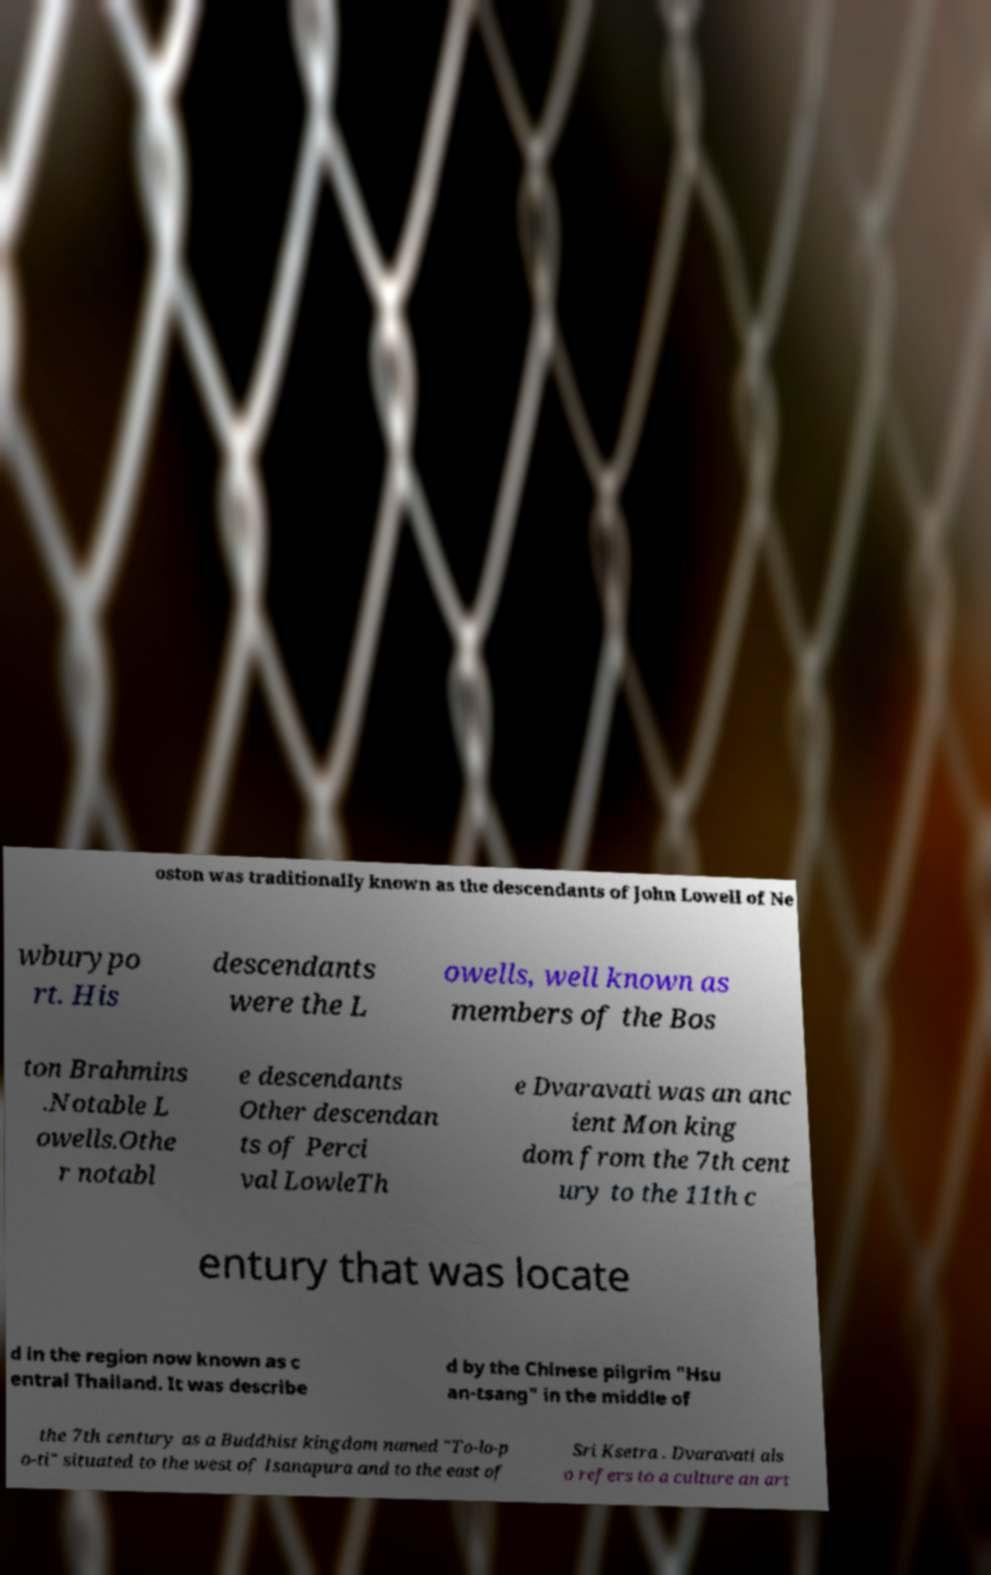What messages or text are displayed in this image? I need them in a readable, typed format. oston was traditionally known as the descendants of John Lowell of Ne wburypo rt. His descendants were the L owells, well known as members of the Bos ton Brahmins .Notable L owells.Othe r notabl e descendants Other descendan ts of Perci val LowleTh e Dvaravati was an anc ient Mon king dom from the 7th cent ury to the 11th c entury that was locate d in the region now known as c entral Thailand. It was describe d by the Chinese pilgrim "Hsu an-tsang" in the middle of the 7th century as a Buddhist kingdom named "To-lo-p o-ti" situated to the west of Isanapura and to the east of Sri Ksetra . Dvaravati als o refers to a culture an art 